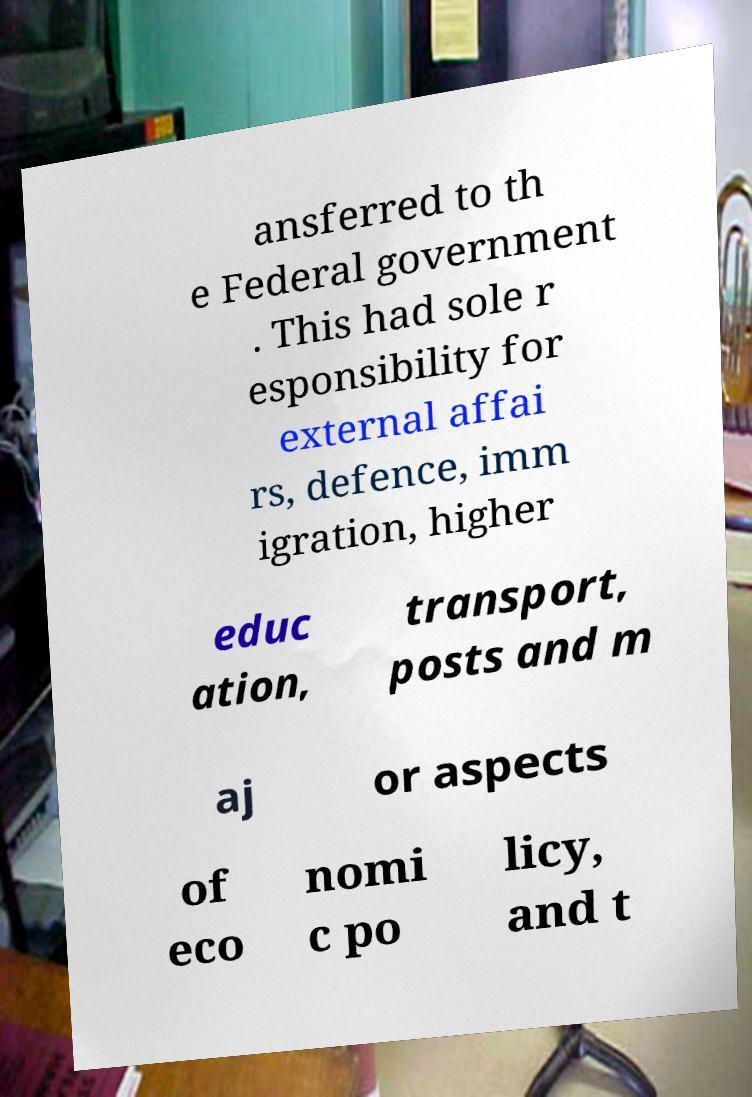Can you accurately transcribe the text from the provided image for me? ansferred to th e Federal government . This had sole r esponsibility for external affai rs, defence, imm igration, higher educ ation, transport, posts and m aj or aspects of eco nomi c po licy, and t 